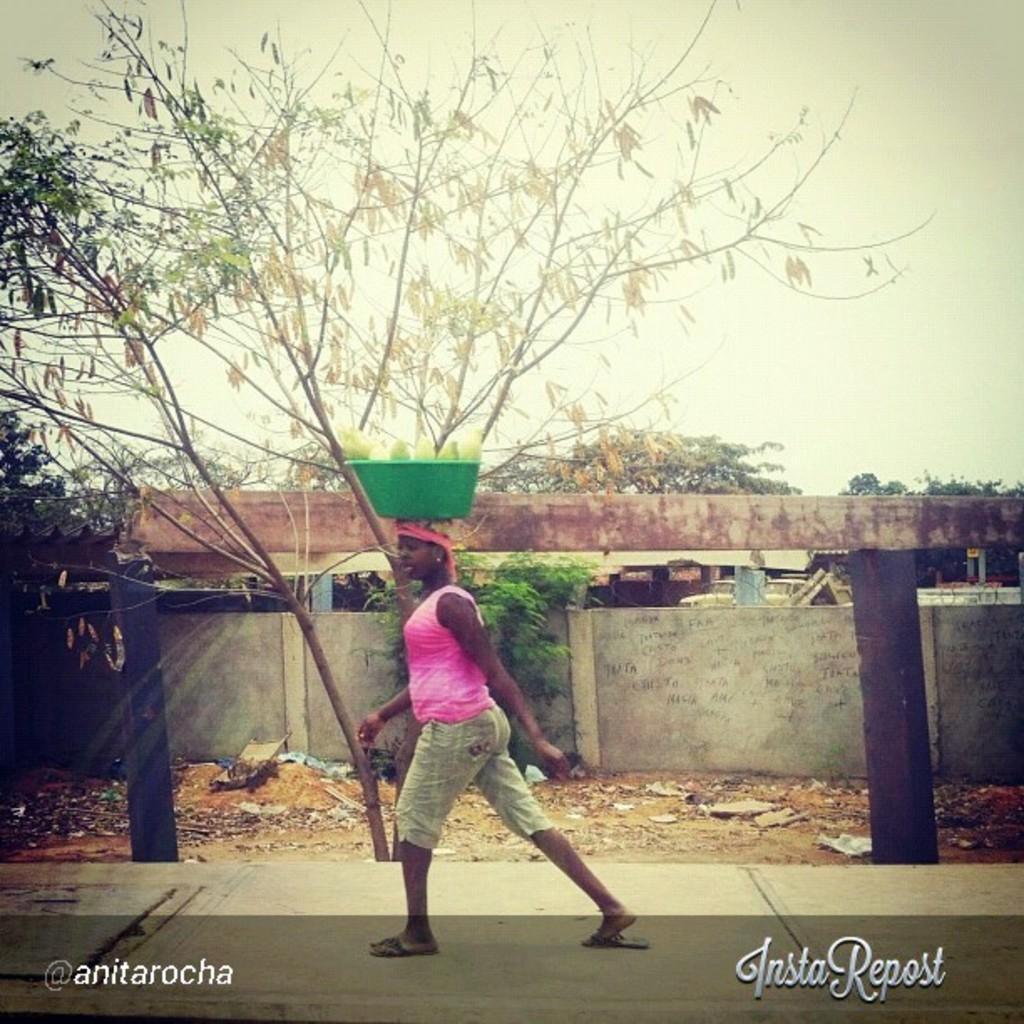In one or two sentences, can you explain what this image depicts? In this picture I can observe a woman walking on the road. There is a green color tub on her head. I can observe poles on either sides of the picture. In the background there is wall, some trees and sky. I can observe watermarks on either sides of the picture, on the bottom. 